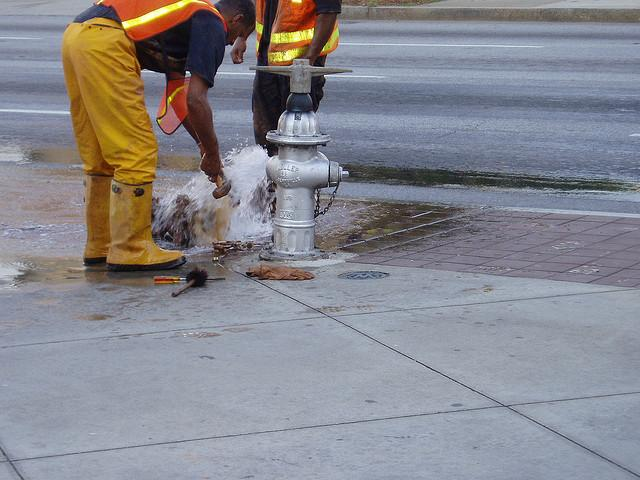Who caused the water to flood out? Please explain your reasoning. these men. The men turned on the hydrant. 